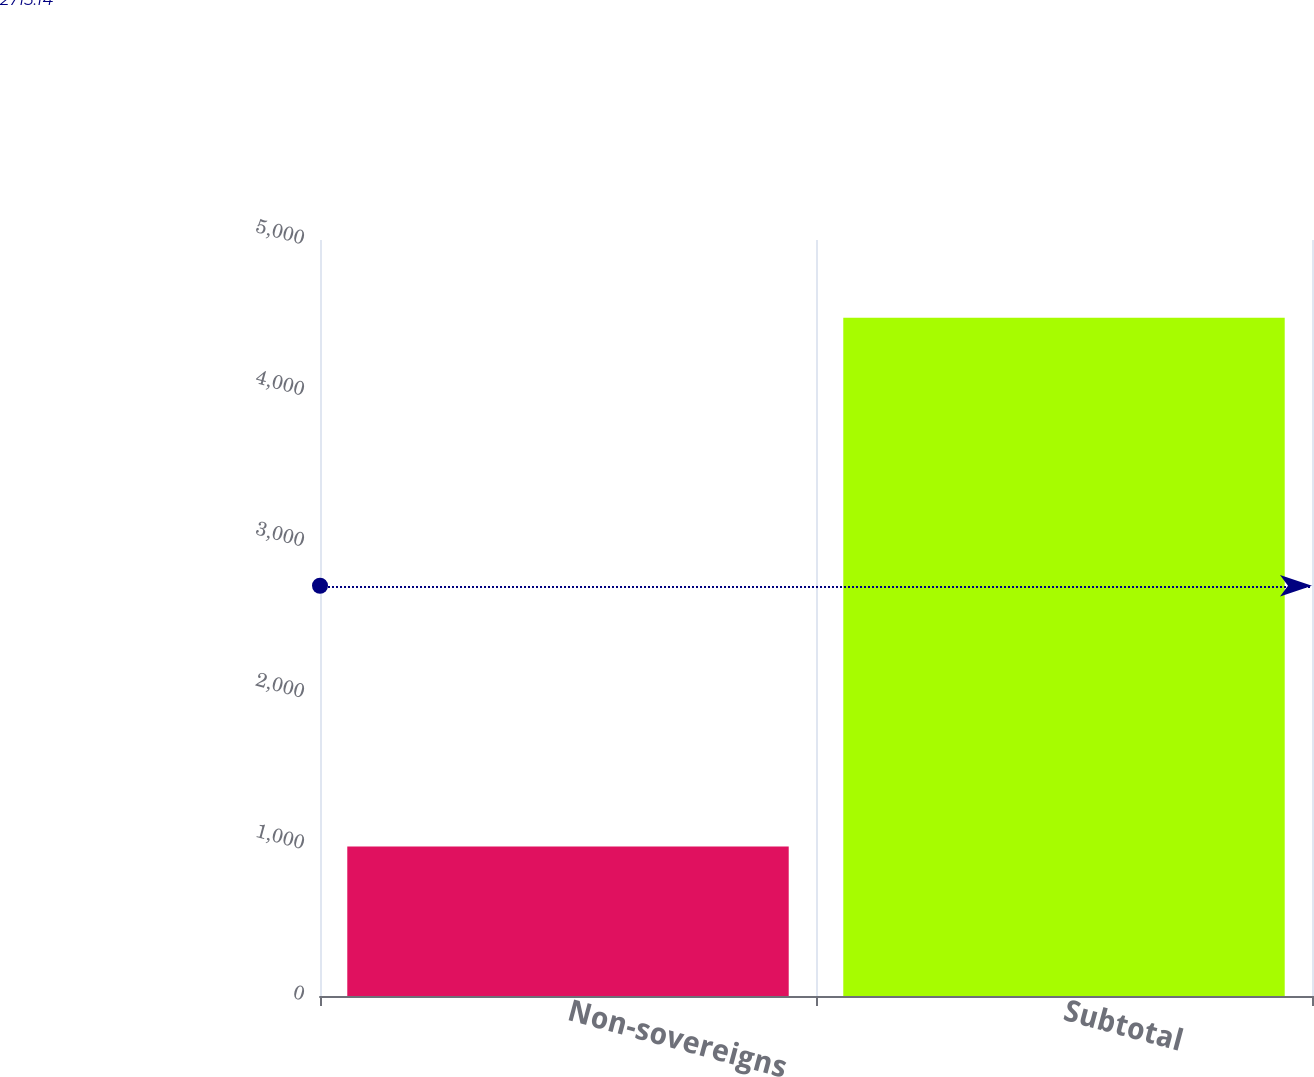Convert chart to OTSL. <chart><loc_0><loc_0><loc_500><loc_500><bar_chart><fcel>Non-sovereigns<fcel>Subtotal<nl><fcel>989<fcel>4486<nl></chart> 